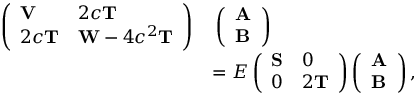<formula> <loc_0><loc_0><loc_500><loc_500>\begin{array} { r l } { \left ( \begin{array} { l l } { V } & { 2 c T } \\ { 2 c T } & { W - 4 c ^ { 2 } T } \end{array} \right ) } & { \, \left ( \begin{array} { l } { A } \\ { B } \end{array} \right ) } \\ & { = E \left ( \begin{array} { l l } { S } & { 0 } \\ { 0 } & { 2 T } \end{array} \right ) \left ( \begin{array} { l } { A } \\ { B } \end{array} \right ) , } \end{array}</formula> 